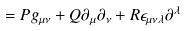<formula> <loc_0><loc_0><loc_500><loc_500>= P g _ { \mu \nu } + Q \partial _ { \mu } \partial _ { \nu } + R \epsilon _ { \mu \nu \lambda } \partial ^ { \lambda }</formula> 